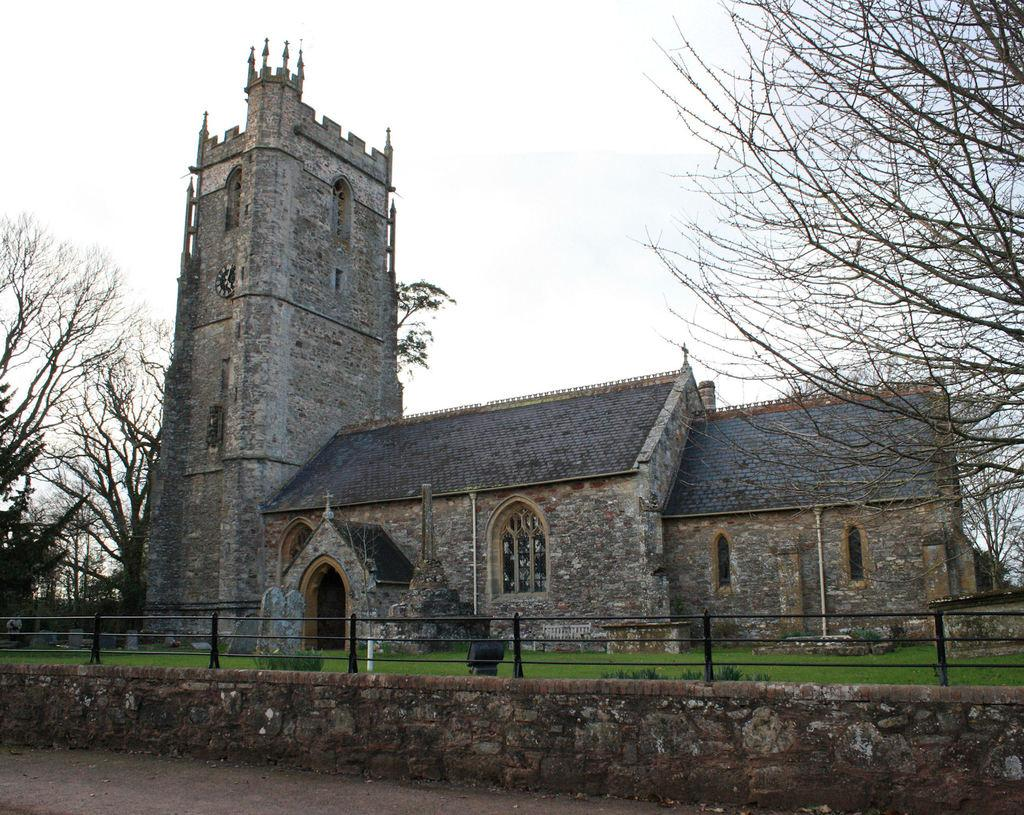What is the main subject in the middle of the image? There is a church in the middle of the image. What type of vegetation can be seen on either side of the image? There are trees on either side of the image. What is visible at the top of the image? The sky is visible at the top of the image. How many desks are present in the image? There are no desks present in the image. What type of thunder can be heard in the image? There is no thunder present in the image, as it is a visual medium and does not include sound. 